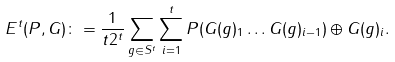Convert formula to latex. <formula><loc_0><loc_0><loc_500><loc_500>E ^ { t } ( P , G ) \colon = \frac { 1 } { t 2 ^ { t } } \sum _ { g \in S ^ { t } } \sum _ { i = 1 } ^ { t } P ( G ( g ) _ { 1 } \dots G ( g ) _ { i - 1 } ) \oplus G ( g ) _ { i } .</formula> 